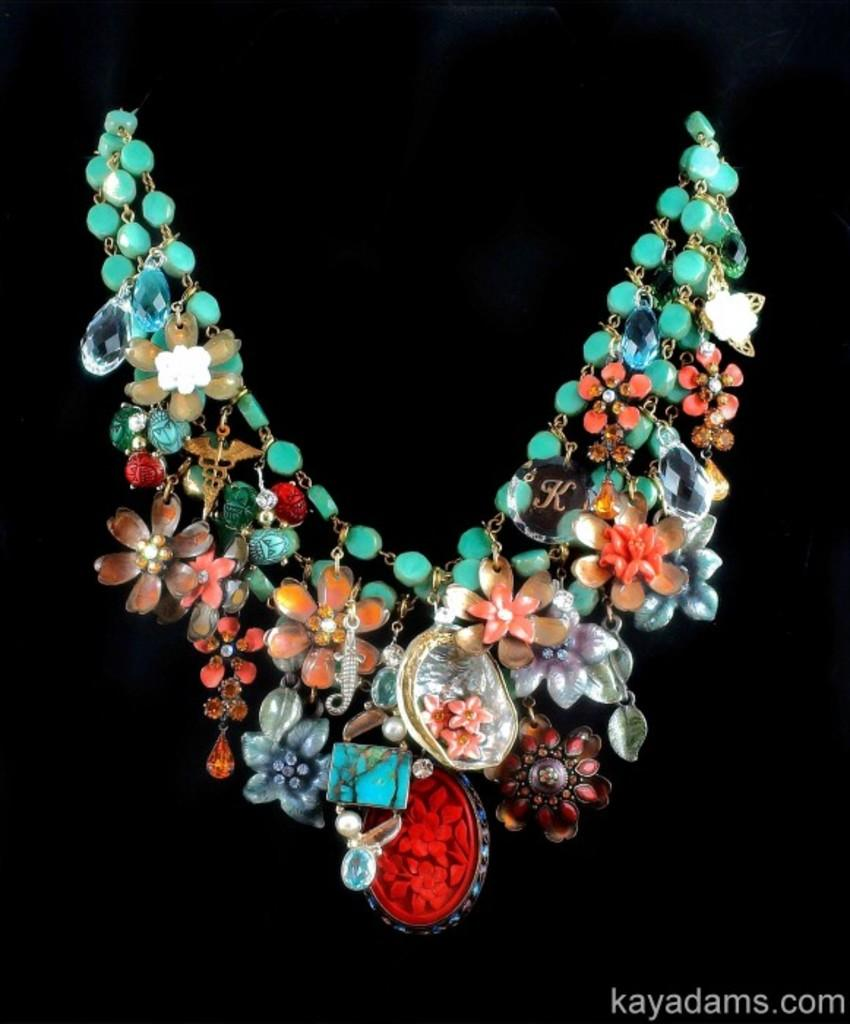What type of jewelry is featured in the image? There is a necklace in the image. What are the main components of the necklace? The necklace has stones, pearls, and pendants. What is the color of the background in the image? The background of the image is black. Is there any additional mark or symbol in the image? Yes, there is a watermark in the right bottom corner of the image. How many eggs are visible in the image? There are no eggs present in the image. What type of glove is being worn by the person in the image? There is no person or glove visible in the image; it features a necklace with stones, pearls, and pendants against a black background. 